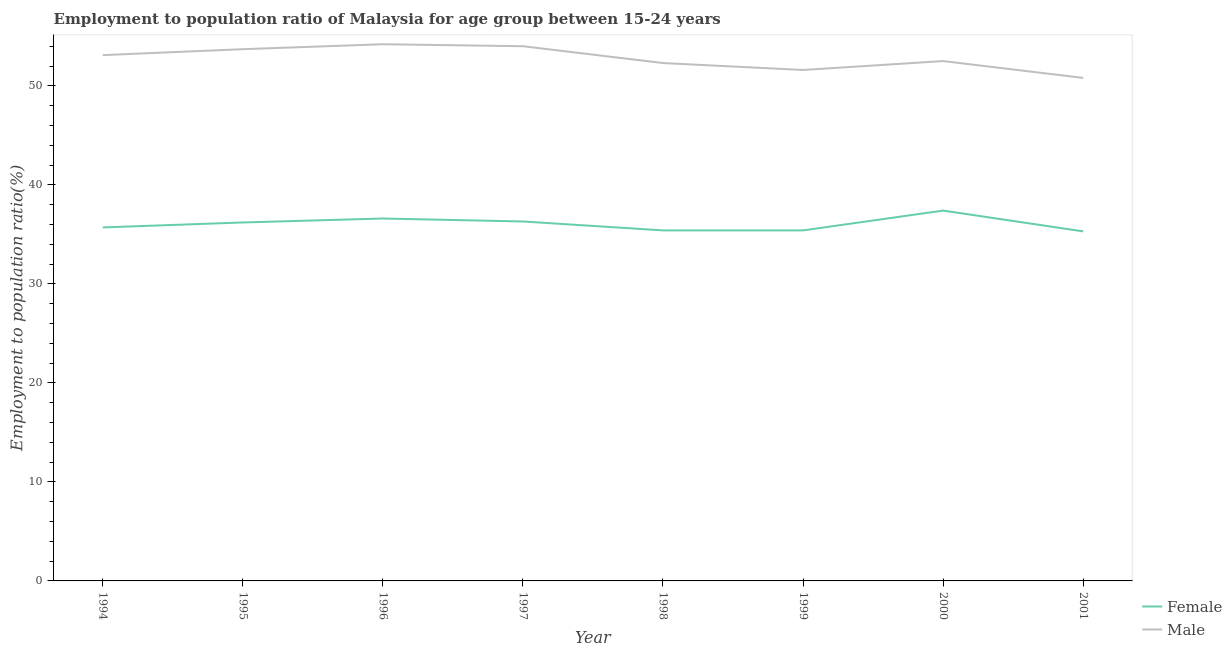Is the number of lines equal to the number of legend labels?
Offer a very short reply. Yes. What is the employment to population ratio(male) in 1994?
Your response must be concise. 53.1. Across all years, what is the maximum employment to population ratio(female)?
Offer a terse response. 37.4. Across all years, what is the minimum employment to population ratio(male)?
Offer a very short reply. 50.8. In which year was the employment to population ratio(male) minimum?
Make the answer very short. 2001. What is the total employment to population ratio(female) in the graph?
Your answer should be compact. 288.3. What is the difference between the employment to population ratio(female) in 1994 and that in 2000?
Keep it short and to the point. -1.7. What is the difference between the employment to population ratio(female) in 1996 and the employment to population ratio(male) in 1995?
Keep it short and to the point. -17.1. What is the average employment to population ratio(female) per year?
Your answer should be compact. 36.04. In the year 1999, what is the difference between the employment to population ratio(male) and employment to population ratio(female)?
Keep it short and to the point. 16.2. In how many years, is the employment to population ratio(male) greater than 36 %?
Keep it short and to the point. 8. What is the ratio of the employment to population ratio(male) in 1994 to that in 1998?
Ensure brevity in your answer.  1.02. Is the difference between the employment to population ratio(female) in 1996 and 1998 greater than the difference between the employment to population ratio(male) in 1996 and 1998?
Keep it short and to the point. No. What is the difference between the highest and the second highest employment to population ratio(male)?
Provide a short and direct response. 0.2. What is the difference between the highest and the lowest employment to population ratio(male)?
Offer a very short reply. 3.4. In how many years, is the employment to population ratio(female) greater than the average employment to population ratio(female) taken over all years?
Provide a short and direct response. 4. Does the employment to population ratio(male) monotonically increase over the years?
Keep it short and to the point. No. What is the difference between two consecutive major ticks on the Y-axis?
Give a very brief answer. 10. Are the values on the major ticks of Y-axis written in scientific E-notation?
Keep it short and to the point. No. Where does the legend appear in the graph?
Your response must be concise. Bottom right. What is the title of the graph?
Your answer should be compact. Employment to population ratio of Malaysia for age group between 15-24 years. Does "DAC donors" appear as one of the legend labels in the graph?
Ensure brevity in your answer.  No. What is the label or title of the X-axis?
Keep it short and to the point. Year. What is the label or title of the Y-axis?
Make the answer very short. Employment to population ratio(%). What is the Employment to population ratio(%) of Female in 1994?
Provide a succinct answer. 35.7. What is the Employment to population ratio(%) in Male in 1994?
Provide a succinct answer. 53.1. What is the Employment to population ratio(%) of Female in 1995?
Your response must be concise. 36.2. What is the Employment to population ratio(%) of Male in 1995?
Your response must be concise. 53.7. What is the Employment to population ratio(%) in Female in 1996?
Give a very brief answer. 36.6. What is the Employment to population ratio(%) in Male in 1996?
Ensure brevity in your answer.  54.2. What is the Employment to population ratio(%) of Female in 1997?
Your answer should be very brief. 36.3. What is the Employment to population ratio(%) of Male in 1997?
Your response must be concise. 54. What is the Employment to population ratio(%) of Female in 1998?
Offer a very short reply. 35.4. What is the Employment to population ratio(%) in Male in 1998?
Provide a succinct answer. 52.3. What is the Employment to population ratio(%) of Female in 1999?
Offer a terse response. 35.4. What is the Employment to population ratio(%) of Male in 1999?
Your answer should be very brief. 51.6. What is the Employment to population ratio(%) of Female in 2000?
Give a very brief answer. 37.4. What is the Employment to population ratio(%) of Male in 2000?
Provide a short and direct response. 52.5. What is the Employment to population ratio(%) of Female in 2001?
Offer a terse response. 35.3. What is the Employment to population ratio(%) in Male in 2001?
Ensure brevity in your answer.  50.8. Across all years, what is the maximum Employment to population ratio(%) of Female?
Offer a very short reply. 37.4. Across all years, what is the maximum Employment to population ratio(%) of Male?
Make the answer very short. 54.2. Across all years, what is the minimum Employment to population ratio(%) in Female?
Provide a succinct answer. 35.3. Across all years, what is the minimum Employment to population ratio(%) of Male?
Your response must be concise. 50.8. What is the total Employment to population ratio(%) of Female in the graph?
Offer a terse response. 288.3. What is the total Employment to population ratio(%) in Male in the graph?
Offer a terse response. 422.2. What is the difference between the Employment to population ratio(%) in Female in 1994 and that in 1996?
Keep it short and to the point. -0.9. What is the difference between the Employment to population ratio(%) in Female in 1994 and that in 1998?
Your response must be concise. 0.3. What is the difference between the Employment to population ratio(%) of Female in 1994 and that in 1999?
Your response must be concise. 0.3. What is the difference between the Employment to population ratio(%) in Male in 1994 and that in 2000?
Keep it short and to the point. 0.6. What is the difference between the Employment to population ratio(%) in Female in 1994 and that in 2001?
Make the answer very short. 0.4. What is the difference between the Employment to population ratio(%) in Male in 1994 and that in 2001?
Offer a very short reply. 2.3. What is the difference between the Employment to population ratio(%) of Female in 1995 and that in 1996?
Your response must be concise. -0.4. What is the difference between the Employment to population ratio(%) of Male in 1995 and that in 1996?
Give a very brief answer. -0.5. What is the difference between the Employment to population ratio(%) in Female in 1995 and that in 1997?
Your answer should be compact. -0.1. What is the difference between the Employment to population ratio(%) of Male in 1995 and that in 1997?
Offer a very short reply. -0.3. What is the difference between the Employment to population ratio(%) in Female in 1995 and that in 1998?
Your response must be concise. 0.8. What is the difference between the Employment to population ratio(%) of Male in 1995 and that in 1999?
Ensure brevity in your answer.  2.1. What is the difference between the Employment to population ratio(%) in Female in 1995 and that in 2000?
Make the answer very short. -1.2. What is the difference between the Employment to population ratio(%) in Male in 1995 and that in 2000?
Give a very brief answer. 1.2. What is the difference between the Employment to population ratio(%) in Female in 1995 and that in 2001?
Your answer should be very brief. 0.9. What is the difference between the Employment to population ratio(%) in Male in 1995 and that in 2001?
Keep it short and to the point. 2.9. What is the difference between the Employment to population ratio(%) of Female in 1996 and that in 1997?
Make the answer very short. 0.3. What is the difference between the Employment to population ratio(%) of Female in 1996 and that in 1998?
Offer a terse response. 1.2. What is the difference between the Employment to population ratio(%) of Male in 1996 and that in 1998?
Offer a terse response. 1.9. What is the difference between the Employment to population ratio(%) of Male in 1996 and that in 1999?
Provide a succinct answer. 2.6. What is the difference between the Employment to population ratio(%) in Female in 1996 and that in 2000?
Ensure brevity in your answer.  -0.8. What is the difference between the Employment to population ratio(%) in Male in 1996 and that in 2001?
Offer a very short reply. 3.4. What is the difference between the Employment to population ratio(%) in Female in 1997 and that in 2001?
Offer a very short reply. 1. What is the difference between the Employment to population ratio(%) in Female in 1998 and that in 2001?
Your response must be concise. 0.1. What is the difference between the Employment to population ratio(%) of Male in 1998 and that in 2001?
Your answer should be very brief. 1.5. What is the difference between the Employment to population ratio(%) of Female in 1999 and that in 2000?
Your answer should be compact. -2. What is the difference between the Employment to population ratio(%) of Male in 1999 and that in 2000?
Ensure brevity in your answer.  -0.9. What is the difference between the Employment to population ratio(%) in Male in 1999 and that in 2001?
Your response must be concise. 0.8. What is the difference between the Employment to population ratio(%) in Male in 2000 and that in 2001?
Offer a very short reply. 1.7. What is the difference between the Employment to population ratio(%) in Female in 1994 and the Employment to population ratio(%) in Male in 1995?
Make the answer very short. -18. What is the difference between the Employment to population ratio(%) in Female in 1994 and the Employment to population ratio(%) in Male in 1996?
Keep it short and to the point. -18.5. What is the difference between the Employment to population ratio(%) of Female in 1994 and the Employment to population ratio(%) of Male in 1997?
Offer a very short reply. -18.3. What is the difference between the Employment to population ratio(%) of Female in 1994 and the Employment to population ratio(%) of Male in 1998?
Your answer should be very brief. -16.6. What is the difference between the Employment to population ratio(%) of Female in 1994 and the Employment to population ratio(%) of Male in 1999?
Ensure brevity in your answer.  -15.9. What is the difference between the Employment to population ratio(%) in Female in 1994 and the Employment to population ratio(%) in Male in 2000?
Provide a succinct answer. -16.8. What is the difference between the Employment to population ratio(%) of Female in 1994 and the Employment to population ratio(%) of Male in 2001?
Ensure brevity in your answer.  -15.1. What is the difference between the Employment to population ratio(%) in Female in 1995 and the Employment to population ratio(%) in Male in 1996?
Offer a very short reply. -18. What is the difference between the Employment to population ratio(%) in Female in 1995 and the Employment to population ratio(%) in Male in 1997?
Your answer should be compact. -17.8. What is the difference between the Employment to population ratio(%) in Female in 1995 and the Employment to population ratio(%) in Male in 1998?
Offer a terse response. -16.1. What is the difference between the Employment to population ratio(%) in Female in 1995 and the Employment to population ratio(%) in Male in 1999?
Ensure brevity in your answer.  -15.4. What is the difference between the Employment to population ratio(%) in Female in 1995 and the Employment to population ratio(%) in Male in 2000?
Provide a short and direct response. -16.3. What is the difference between the Employment to population ratio(%) in Female in 1995 and the Employment to population ratio(%) in Male in 2001?
Offer a terse response. -14.6. What is the difference between the Employment to population ratio(%) of Female in 1996 and the Employment to population ratio(%) of Male in 1997?
Offer a terse response. -17.4. What is the difference between the Employment to population ratio(%) of Female in 1996 and the Employment to population ratio(%) of Male in 1998?
Make the answer very short. -15.7. What is the difference between the Employment to population ratio(%) in Female in 1996 and the Employment to population ratio(%) in Male in 2000?
Provide a succinct answer. -15.9. What is the difference between the Employment to population ratio(%) of Female in 1996 and the Employment to population ratio(%) of Male in 2001?
Provide a short and direct response. -14.2. What is the difference between the Employment to population ratio(%) in Female in 1997 and the Employment to population ratio(%) in Male in 1999?
Ensure brevity in your answer.  -15.3. What is the difference between the Employment to population ratio(%) in Female in 1997 and the Employment to population ratio(%) in Male in 2000?
Your response must be concise. -16.2. What is the difference between the Employment to population ratio(%) in Female in 1998 and the Employment to population ratio(%) in Male in 1999?
Your answer should be very brief. -16.2. What is the difference between the Employment to population ratio(%) of Female in 1998 and the Employment to population ratio(%) of Male in 2000?
Provide a short and direct response. -17.1. What is the difference between the Employment to population ratio(%) in Female in 1998 and the Employment to population ratio(%) in Male in 2001?
Your answer should be compact. -15.4. What is the difference between the Employment to population ratio(%) in Female in 1999 and the Employment to population ratio(%) in Male in 2000?
Provide a succinct answer. -17.1. What is the difference between the Employment to population ratio(%) of Female in 1999 and the Employment to population ratio(%) of Male in 2001?
Keep it short and to the point. -15.4. What is the average Employment to population ratio(%) of Female per year?
Offer a very short reply. 36.04. What is the average Employment to population ratio(%) of Male per year?
Offer a very short reply. 52.77. In the year 1994, what is the difference between the Employment to population ratio(%) in Female and Employment to population ratio(%) in Male?
Offer a very short reply. -17.4. In the year 1995, what is the difference between the Employment to population ratio(%) in Female and Employment to population ratio(%) in Male?
Offer a terse response. -17.5. In the year 1996, what is the difference between the Employment to population ratio(%) of Female and Employment to population ratio(%) of Male?
Keep it short and to the point. -17.6. In the year 1997, what is the difference between the Employment to population ratio(%) in Female and Employment to population ratio(%) in Male?
Provide a short and direct response. -17.7. In the year 1998, what is the difference between the Employment to population ratio(%) in Female and Employment to population ratio(%) in Male?
Offer a terse response. -16.9. In the year 1999, what is the difference between the Employment to population ratio(%) of Female and Employment to population ratio(%) of Male?
Your answer should be compact. -16.2. In the year 2000, what is the difference between the Employment to population ratio(%) of Female and Employment to population ratio(%) of Male?
Ensure brevity in your answer.  -15.1. In the year 2001, what is the difference between the Employment to population ratio(%) in Female and Employment to population ratio(%) in Male?
Provide a short and direct response. -15.5. What is the ratio of the Employment to population ratio(%) of Female in 1994 to that in 1995?
Give a very brief answer. 0.99. What is the ratio of the Employment to population ratio(%) of Female in 1994 to that in 1996?
Your answer should be very brief. 0.98. What is the ratio of the Employment to population ratio(%) in Male in 1994 to that in 1996?
Your answer should be compact. 0.98. What is the ratio of the Employment to population ratio(%) of Female in 1994 to that in 1997?
Provide a short and direct response. 0.98. What is the ratio of the Employment to population ratio(%) of Male in 1994 to that in 1997?
Provide a short and direct response. 0.98. What is the ratio of the Employment to population ratio(%) of Female in 1994 to that in 1998?
Ensure brevity in your answer.  1.01. What is the ratio of the Employment to population ratio(%) of Male in 1994 to that in 1998?
Provide a succinct answer. 1.02. What is the ratio of the Employment to population ratio(%) of Female in 1994 to that in 1999?
Your response must be concise. 1.01. What is the ratio of the Employment to population ratio(%) of Male in 1994 to that in 1999?
Your response must be concise. 1.03. What is the ratio of the Employment to population ratio(%) of Female in 1994 to that in 2000?
Offer a terse response. 0.95. What is the ratio of the Employment to population ratio(%) in Male in 1994 to that in 2000?
Offer a terse response. 1.01. What is the ratio of the Employment to population ratio(%) in Female in 1994 to that in 2001?
Your answer should be compact. 1.01. What is the ratio of the Employment to population ratio(%) in Male in 1994 to that in 2001?
Keep it short and to the point. 1.05. What is the ratio of the Employment to population ratio(%) in Male in 1995 to that in 1997?
Ensure brevity in your answer.  0.99. What is the ratio of the Employment to population ratio(%) of Female in 1995 to that in 1998?
Offer a very short reply. 1.02. What is the ratio of the Employment to population ratio(%) in Male in 1995 to that in 1998?
Give a very brief answer. 1.03. What is the ratio of the Employment to population ratio(%) in Female in 1995 to that in 1999?
Your answer should be very brief. 1.02. What is the ratio of the Employment to population ratio(%) in Male in 1995 to that in 1999?
Your answer should be very brief. 1.04. What is the ratio of the Employment to population ratio(%) in Female in 1995 to that in 2000?
Offer a terse response. 0.97. What is the ratio of the Employment to population ratio(%) in Male in 1995 to that in 2000?
Keep it short and to the point. 1.02. What is the ratio of the Employment to population ratio(%) of Female in 1995 to that in 2001?
Make the answer very short. 1.03. What is the ratio of the Employment to population ratio(%) of Male in 1995 to that in 2001?
Provide a short and direct response. 1.06. What is the ratio of the Employment to population ratio(%) in Female in 1996 to that in 1997?
Your answer should be very brief. 1.01. What is the ratio of the Employment to population ratio(%) of Female in 1996 to that in 1998?
Offer a terse response. 1.03. What is the ratio of the Employment to population ratio(%) in Male in 1996 to that in 1998?
Keep it short and to the point. 1.04. What is the ratio of the Employment to population ratio(%) of Female in 1996 to that in 1999?
Your answer should be very brief. 1.03. What is the ratio of the Employment to population ratio(%) in Male in 1996 to that in 1999?
Keep it short and to the point. 1.05. What is the ratio of the Employment to population ratio(%) in Female in 1996 to that in 2000?
Your answer should be very brief. 0.98. What is the ratio of the Employment to population ratio(%) of Male in 1996 to that in 2000?
Offer a terse response. 1.03. What is the ratio of the Employment to population ratio(%) of Female in 1996 to that in 2001?
Your answer should be very brief. 1.04. What is the ratio of the Employment to population ratio(%) in Male in 1996 to that in 2001?
Provide a short and direct response. 1.07. What is the ratio of the Employment to population ratio(%) in Female in 1997 to that in 1998?
Provide a succinct answer. 1.03. What is the ratio of the Employment to population ratio(%) in Male in 1997 to that in 1998?
Provide a succinct answer. 1.03. What is the ratio of the Employment to population ratio(%) in Female in 1997 to that in 1999?
Your answer should be very brief. 1.03. What is the ratio of the Employment to population ratio(%) of Male in 1997 to that in 1999?
Keep it short and to the point. 1.05. What is the ratio of the Employment to population ratio(%) of Female in 1997 to that in 2000?
Offer a very short reply. 0.97. What is the ratio of the Employment to population ratio(%) in Male in 1997 to that in 2000?
Your answer should be compact. 1.03. What is the ratio of the Employment to population ratio(%) in Female in 1997 to that in 2001?
Keep it short and to the point. 1.03. What is the ratio of the Employment to population ratio(%) of Male in 1997 to that in 2001?
Your response must be concise. 1.06. What is the ratio of the Employment to population ratio(%) of Male in 1998 to that in 1999?
Give a very brief answer. 1.01. What is the ratio of the Employment to population ratio(%) in Female in 1998 to that in 2000?
Your response must be concise. 0.95. What is the ratio of the Employment to population ratio(%) in Male in 1998 to that in 2001?
Give a very brief answer. 1.03. What is the ratio of the Employment to population ratio(%) of Female in 1999 to that in 2000?
Your answer should be compact. 0.95. What is the ratio of the Employment to population ratio(%) of Male in 1999 to that in 2000?
Offer a very short reply. 0.98. What is the ratio of the Employment to population ratio(%) of Male in 1999 to that in 2001?
Ensure brevity in your answer.  1.02. What is the ratio of the Employment to population ratio(%) in Female in 2000 to that in 2001?
Offer a terse response. 1.06. What is the ratio of the Employment to population ratio(%) of Male in 2000 to that in 2001?
Give a very brief answer. 1.03. What is the difference between the highest and the second highest Employment to population ratio(%) of Female?
Your response must be concise. 0.8. What is the difference between the highest and the second highest Employment to population ratio(%) of Male?
Provide a succinct answer. 0.2. 